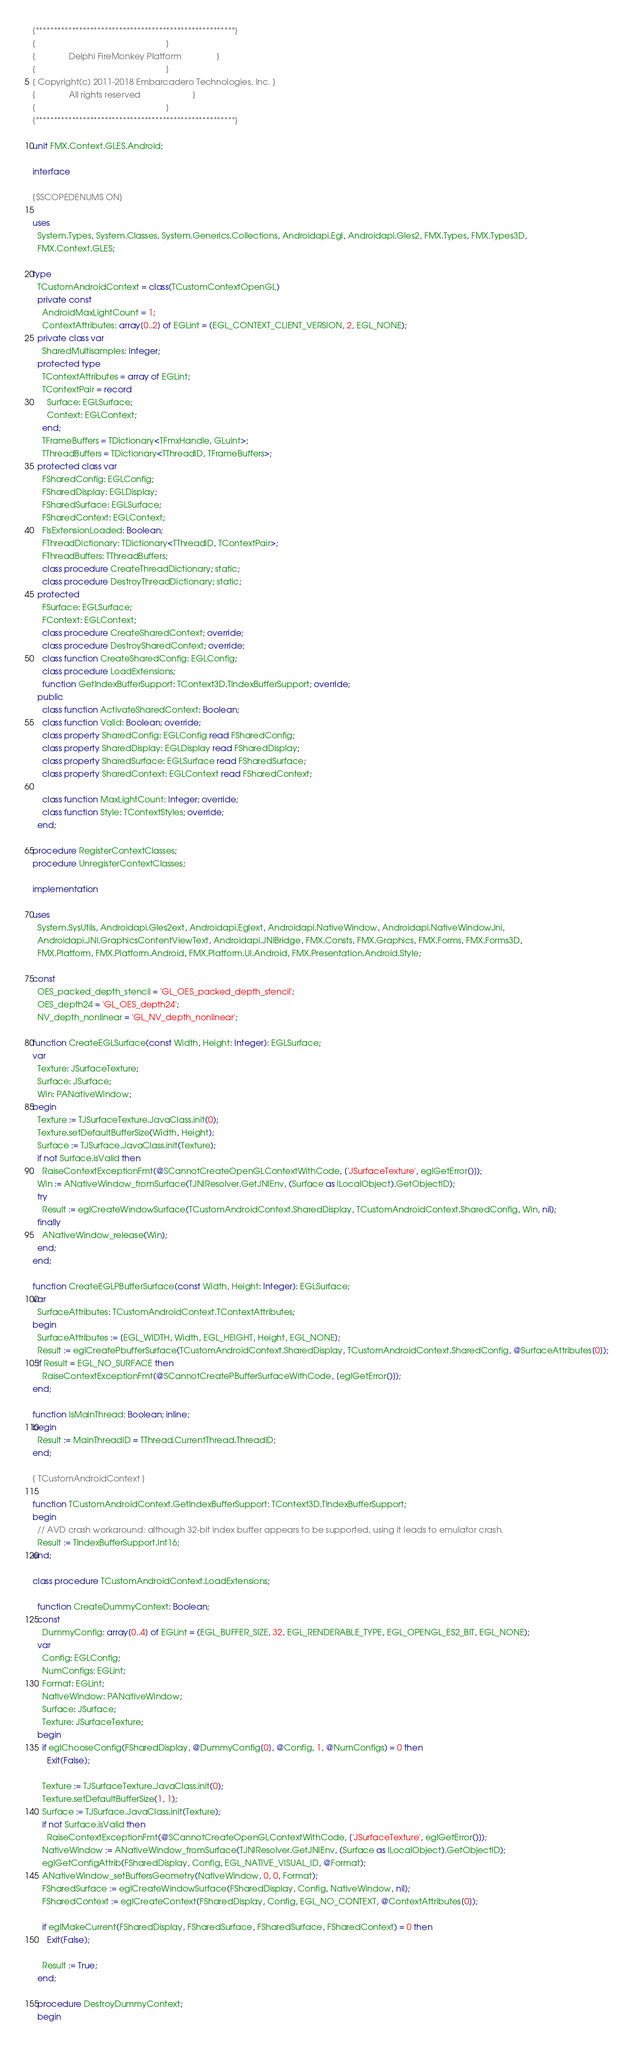Convert code to text. <code><loc_0><loc_0><loc_500><loc_500><_Pascal_>{*******************************************************}
{                                                       }
{              Delphi FireMonkey Platform               }
{                                                       }
{ Copyright(c) 2011-2018 Embarcadero Technologies, Inc. }
{              All rights reserved                      }
{                                                       }
{*******************************************************}

unit FMX.Context.GLES.Android;

interface

{$SCOPEDENUMS ON}

uses
  System.Types, System.Classes, System.Generics.Collections, Androidapi.Egl, Androidapi.Gles2, FMX.Types, FMX.Types3D,
  FMX.Context.GLES;

type
  TCustomAndroidContext = class(TCustomContextOpenGL)
  private const
    AndroidMaxLightCount = 1;
    ContextAttributes: array[0..2] of EGLint = (EGL_CONTEXT_CLIENT_VERSION, 2, EGL_NONE);
  private class var
    SharedMultisamples: Integer;
  protected type
    TContextAttributes = array of EGLint;
    TContextPair = record
      Surface: EGLSurface;
      Context: EGLContext;
    end;
    TFrameBuffers = TDictionary<TFmxHandle, GLuint>;
    TThreadBuffers = TDictionary<TThreadID, TFrameBuffers>;
  protected class var
    FSharedConfig: EGLConfig;
    FSharedDisplay: EGLDisplay;
    FSharedSurface: EGLSurface;
    FSharedContext: EGLContext;
    FIsExtensionLoaded: Boolean;
    FThreadDictionary: TDictionary<TThreadID, TContextPair>;
    FThreadBuffers: TThreadBuffers;
    class procedure CreateThreadDictionary; static;
    class procedure DestroyThreadDictionary; static;
  protected
    FSurface: EGLSurface;
    FContext: EGLContext;
    class procedure CreateSharedContext; override;
    class procedure DestroySharedContext; override;
    class function CreateSharedConfig: EGLConfig;
    class procedure LoadExtensions;
    function GetIndexBufferSupport: TContext3D.TIndexBufferSupport; override;
  public
    class function ActivateSharedContext: Boolean;
    class function Valid: Boolean; override;
    class property SharedConfig: EGLConfig read FSharedConfig;
    class property SharedDisplay: EGLDisplay read FSharedDisplay;
    class property SharedSurface: EGLSurface read FSharedSurface;
    class property SharedContext: EGLContext read FSharedContext;

    class function MaxLightCount: Integer; override;
    class function Style: TContextStyles; override;
  end;

procedure RegisterContextClasses;
procedure UnregisterContextClasses;

implementation

uses
  System.SysUtils, Androidapi.Gles2ext, Androidapi.Eglext, Androidapi.NativeWindow, Androidapi.NativeWindowJni,
  Androidapi.JNI.GraphicsContentViewText, Androidapi.JNIBridge, FMX.Consts, FMX.Graphics, FMX.Forms, FMX.Forms3D,
  FMX.Platform, FMX.Platform.Android, FMX.Platform.UI.Android, FMX.Presentation.Android.Style;

const
  OES_packed_depth_stencil = 'GL_OES_packed_depth_stencil';
  OES_depth24 = 'GL_OES_depth24';
  NV_depth_nonlinear = 'GL_NV_depth_nonlinear';

function CreateEGLSurface(const Width, Height: Integer): EGLSurface;
var
  Texture: JSurfaceTexture;
  Surface: JSurface;
  Win: PANativeWindow;
begin
  Texture := TJSurfaceTexture.JavaClass.init(0);
  Texture.setDefaultBufferSize(Width, Height);
  Surface := TJSurface.JavaClass.init(Texture);
  if not Surface.isValid then
    RaiseContextExceptionFmt(@SCannotCreateOpenGLContextWithCode, ['JSurfaceTexture', eglGetError()]);
  Win := ANativeWindow_fromSurface(TJNIResolver.GetJNIEnv, (Surface as ILocalObject).GetObjectID);
  try
    Result := eglCreateWindowSurface(TCustomAndroidContext.SharedDisplay, TCustomAndroidContext.SharedConfig, Win, nil);
  finally
    ANativeWindow_release(Win);
  end;
end;

function CreateEGLPBufferSurface(const Width, Height: Integer): EGLSurface;
var
  SurfaceAttributes: TCustomAndroidContext.TContextAttributes;
begin
  SurfaceAttributes := [EGL_WIDTH, Width, EGL_HEIGHT, Height, EGL_NONE];
  Result := eglCreatePbufferSurface(TCustomAndroidContext.SharedDisplay, TCustomAndroidContext.SharedConfig, @SurfaceAttributes[0]);
  if Result = EGL_NO_SURFACE then
    RaiseContextExceptionFmt(@SCannotCreatePBufferSurfaceWithCode, [eglGetError()]);
end;

function IsMainThread: Boolean; inline;
begin
  Result := MainThreadID = TThread.CurrentThread.ThreadID;
end;

{ TCustomAndroidContext }

function TCustomAndroidContext.GetIndexBufferSupport: TContext3D.TIndexBufferSupport;
begin
  // AVD crash workaround: although 32-bit index buffer appears to be supported, using it leads to emulator crash.
  Result := TIndexBufferSupport.Int16;
end;

class procedure TCustomAndroidContext.LoadExtensions;

  function CreateDummyContext: Boolean;
  const
    DummyConfig: array[0..4] of EGLint = (EGL_BUFFER_SIZE, 32, EGL_RENDERABLE_TYPE, EGL_OPENGL_ES2_BIT, EGL_NONE);
  var
    Config: EGLConfig;
    NumConfigs: EGLint;
    Format: EGLint;
    NativeWindow: PANativeWindow;
    Surface: JSurface;
    Texture: JSurfaceTexture;
  begin
    if eglChooseConfig(FSharedDisplay, @DummyConfig[0], @Config, 1, @NumConfigs) = 0 then
      Exit(False);

    Texture := TJSurfaceTexture.JavaClass.init(0);
    Texture.setDefaultBufferSize(1, 1);
    Surface := TJSurface.JavaClass.init(Texture);
    if not Surface.isValid then
      RaiseContextExceptionFmt(@SCannotCreateOpenGLContextWithCode, ['JSurfaceTexture', eglGetError()]);
    NativeWindow := ANativeWindow_fromSurface(TJNIResolver.GetJNIEnv, (Surface as ILocalObject).GetObjectID);
    eglGetConfigAttrib(FSharedDisplay, Config, EGL_NATIVE_VISUAL_ID, @Format);
    ANativeWindow_setBuffersGeometry(NativeWindow, 0, 0, Format);
    FSharedSurface := eglCreateWindowSurface(FSharedDisplay, Config, NativeWindow, nil);
    FSharedContext := eglCreateContext(FSharedDisplay, Config, EGL_NO_CONTEXT, @ContextAttributes[0]);

    if eglMakeCurrent(FSharedDisplay, FSharedSurface, FSharedSurface, FSharedContext) = 0 then
      Exit(False);

    Result := True;
  end;

  procedure DestroyDummyContext;
  begin</code> 